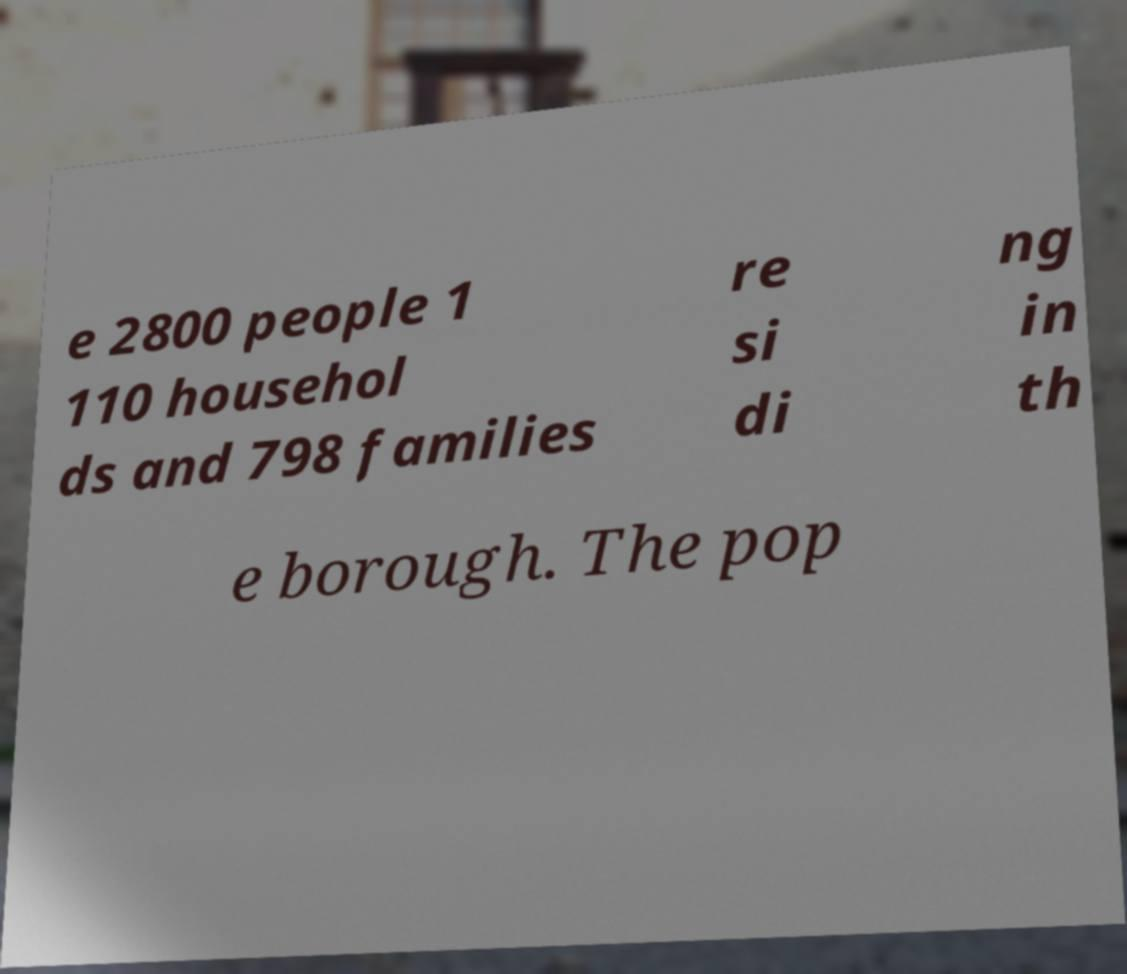Could you assist in decoding the text presented in this image and type it out clearly? e 2800 people 1 110 househol ds and 798 families re si di ng in th e borough. The pop 